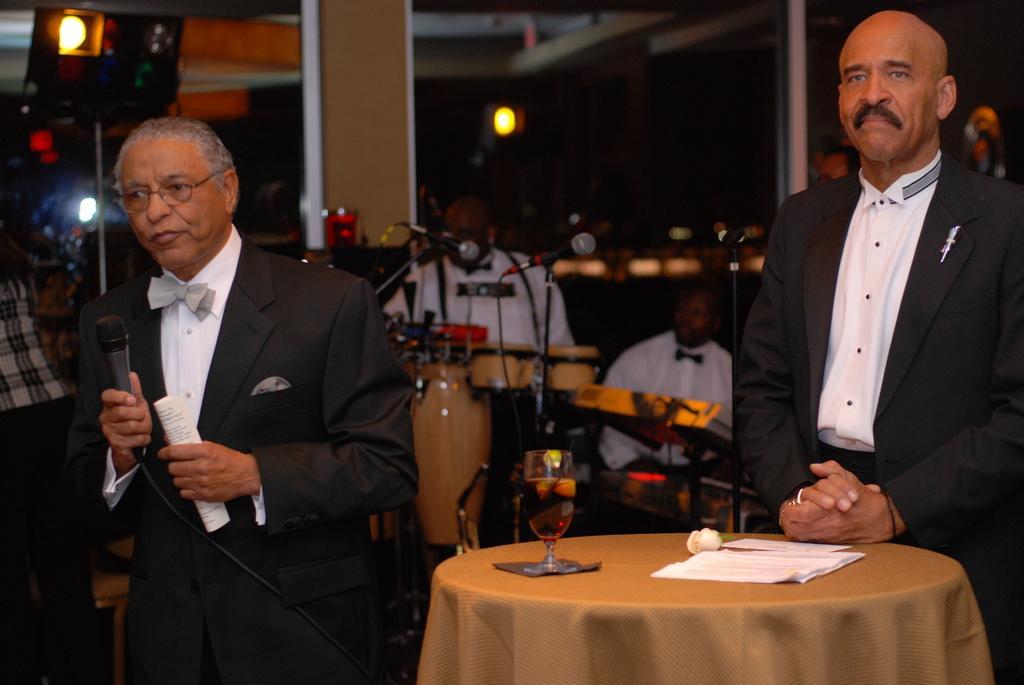Can you describe this image briefly? In the left, a person is standing and speaking in the mike. In the right, a person is standing in front of the table on which wine glass and papers are kept. In the background, two person are sitting and playing drums in front of the mike. In the background lights are visible. And people are standing. A pillar is of light brown in color. This image is taken inside a hall during night time. 